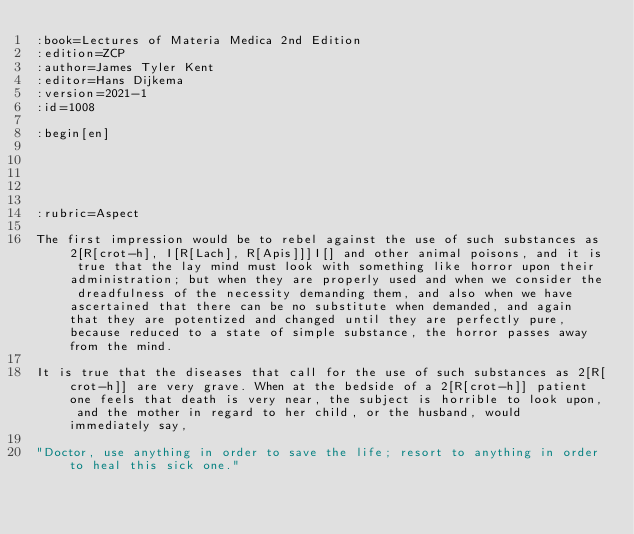<code> <loc_0><loc_0><loc_500><loc_500><_ObjectiveC_>:book=Lectures of Materia Medica 2nd Edition
:edition=ZCP
:author=James Tyler Kent
:editor=Hans Dijkema
:version=2021-1
:id=1008

:begin[en]





:rubric=Aspect

The first impression would be to rebel against the use of such substances as 2[R[crot-h], I[R[Lach], R[Apis]]]I[] and other animal poisons, and it is true that the lay mind must look with something like horror upon their administration; but when they are properly used and when we consider the dreadfulness of the necessity demanding them, and also when we have ascertained that there can be no substitute when demanded, and again that they are potentized and changed until they are perfectly pure, because reduced to a state of simple substance, the horror passes away from the mind.

It is true that the diseases that call for the use of such substances as 2[R[crot-h]] are very grave. When at the bedside of a 2[R[crot-h]] patient one feels that death is very near, the subject is horrible to look upon, and the mother in regard to her child, or the husband, would immediately say,

"Doctor, use anything in order to save the life; resort to anything in order to heal this sick one."
</code> 